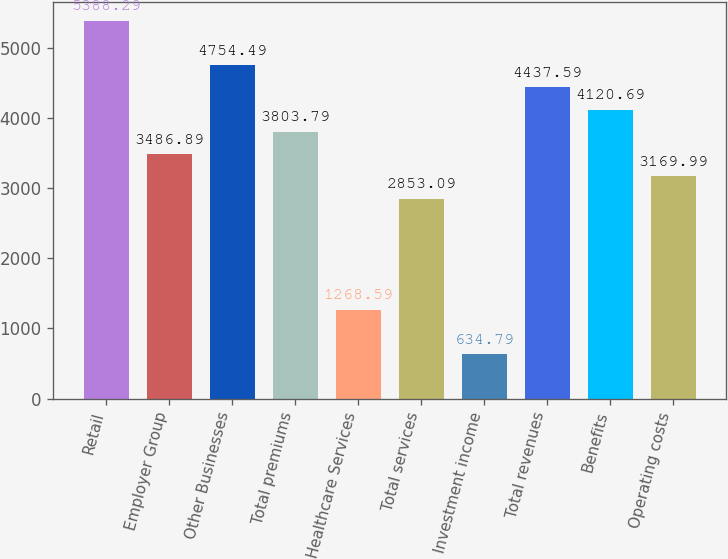Convert chart to OTSL. <chart><loc_0><loc_0><loc_500><loc_500><bar_chart><fcel>Retail<fcel>Employer Group<fcel>Other Businesses<fcel>Total premiums<fcel>Healthcare Services<fcel>Total services<fcel>Investment income<fcel>Total revenues<fcel>Benefits<fcel>Operating costs<nl><fcel>5388.29<fcel>3486.89<fcel>4754.49<fcel>3803.79<fcel>1268.59<fcel>2853.09<fcel>634.79<fcel>4437.59<fcel>4120.69<fcel>3169.99<nl></chart> 